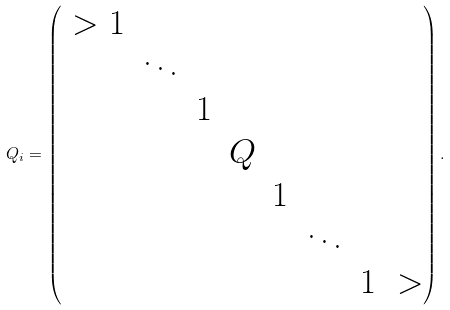Convert formula to latex. <formula><loc_0><loc_0><loc_500><loc_500>Q _ { i } = \begin{pmatrix} \ > 1 & & & & & & \\ & \ddots & & & & & \\ & & 1 & & & & \\ & & & Q & & & \\ & & & & 1 & & \\ & & & & & \ddots & \\ & & & & & & 1 \ > \\ \end{pmatrix} .</formula> 